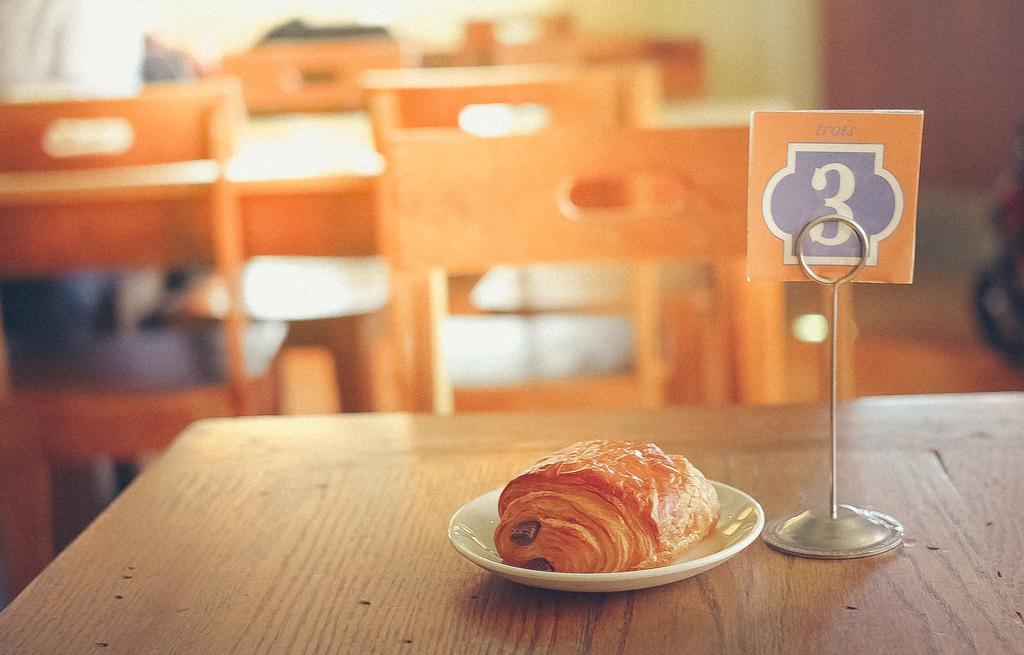In one or two sentences, can you explain what this image depicts? In the picture we can see a table on it, we can see a small plate with a food item on it and beside it, we can see a card no 3 and behind the table we can see some other tables and chairs near it. 